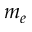<formula> <loc_0><loc_0><loc_500><loc_500>m _ { e }</formula> 